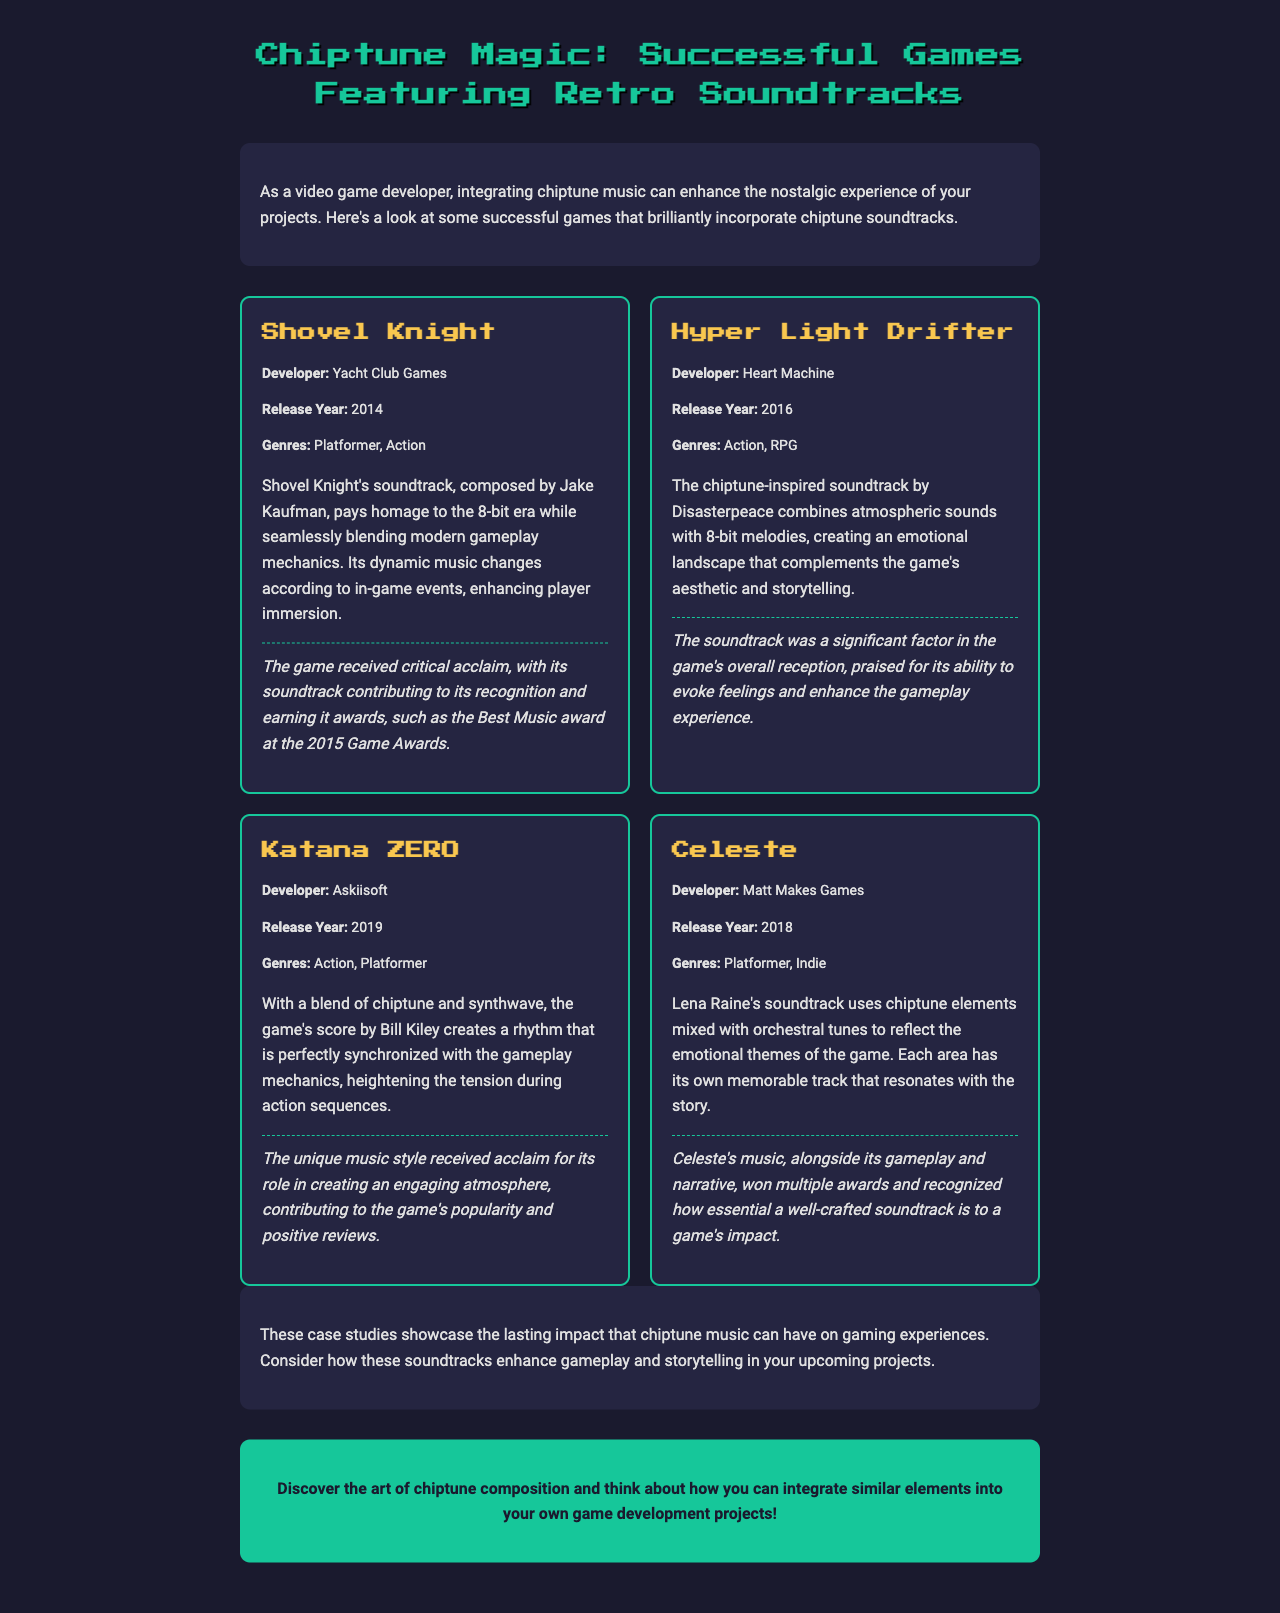What is the title of the newsletter? The title is mentioned at the top of the document, highlighting the focus on chiptune music in games.
Answer: Chiptune Magic: Successful Games Featuring Retro Soundtracks Who developed Shovel Knight? The document states the developer of Shovel Knight within the case study information.
Answer: Yacht Club Games In what year was Hyper Light Drifter released? The release year is specified under the game info for Hyper Light Drifter.
Answer: 2016 Which game’s soundtrack was composed by Lena Raine? This information can be found in the case study section describing the game Celeste.
Answer: Celeste What genre does Katana ZERO belong to? The genres of Katana ZERO are listed within the game info section of the case study.
Answer: Action, Platformer What was a significant factor in Hyper Light Drifter's reception? The case study points out the impact of the soundtrack on the game's overall reception.
Answer: Soundtrack What type of elements does the Celeste soundtrack use? The document describes the mix of elements used in the soundtrack of Celeste.
Answer: Chiptune elements mixed with orchestral tunes Which award did Shovel Knight's soundtrack win? The award is noted in the impact section of the Shovel Knight case study.
Answer: Best Music award at the 2015 Game Awards What is the main theme used in the soundtracks of these case studies? The document collectively emphasizes the nostalgic experience brought by the soundtracks.
Answer: Nostalgia 